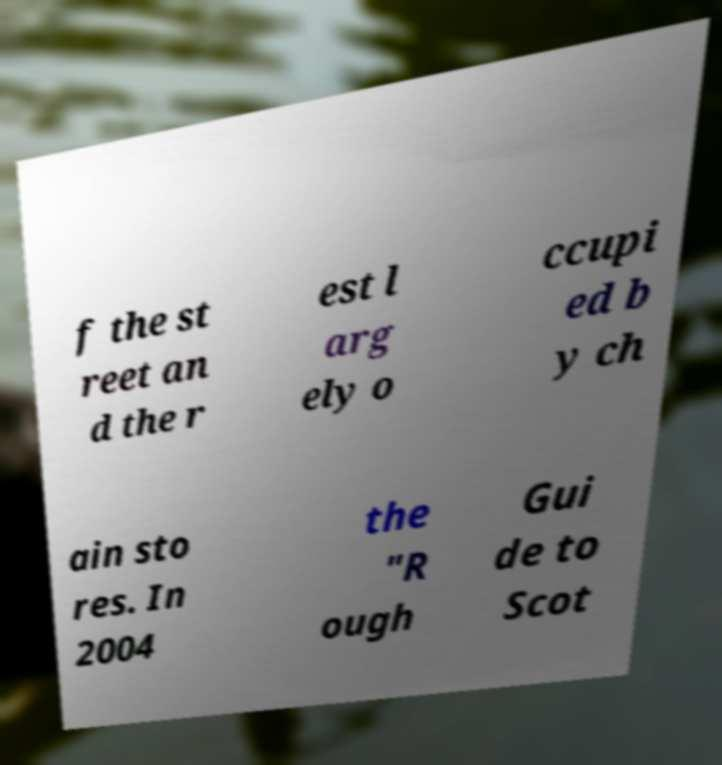For documentation purposes, I need the text within this image transcribed. Could you provide that? f the st reet an d the r est l arg ely o ccupi ed b y ch ain sto res. In 2004 the "R ough Gui de to Scot 